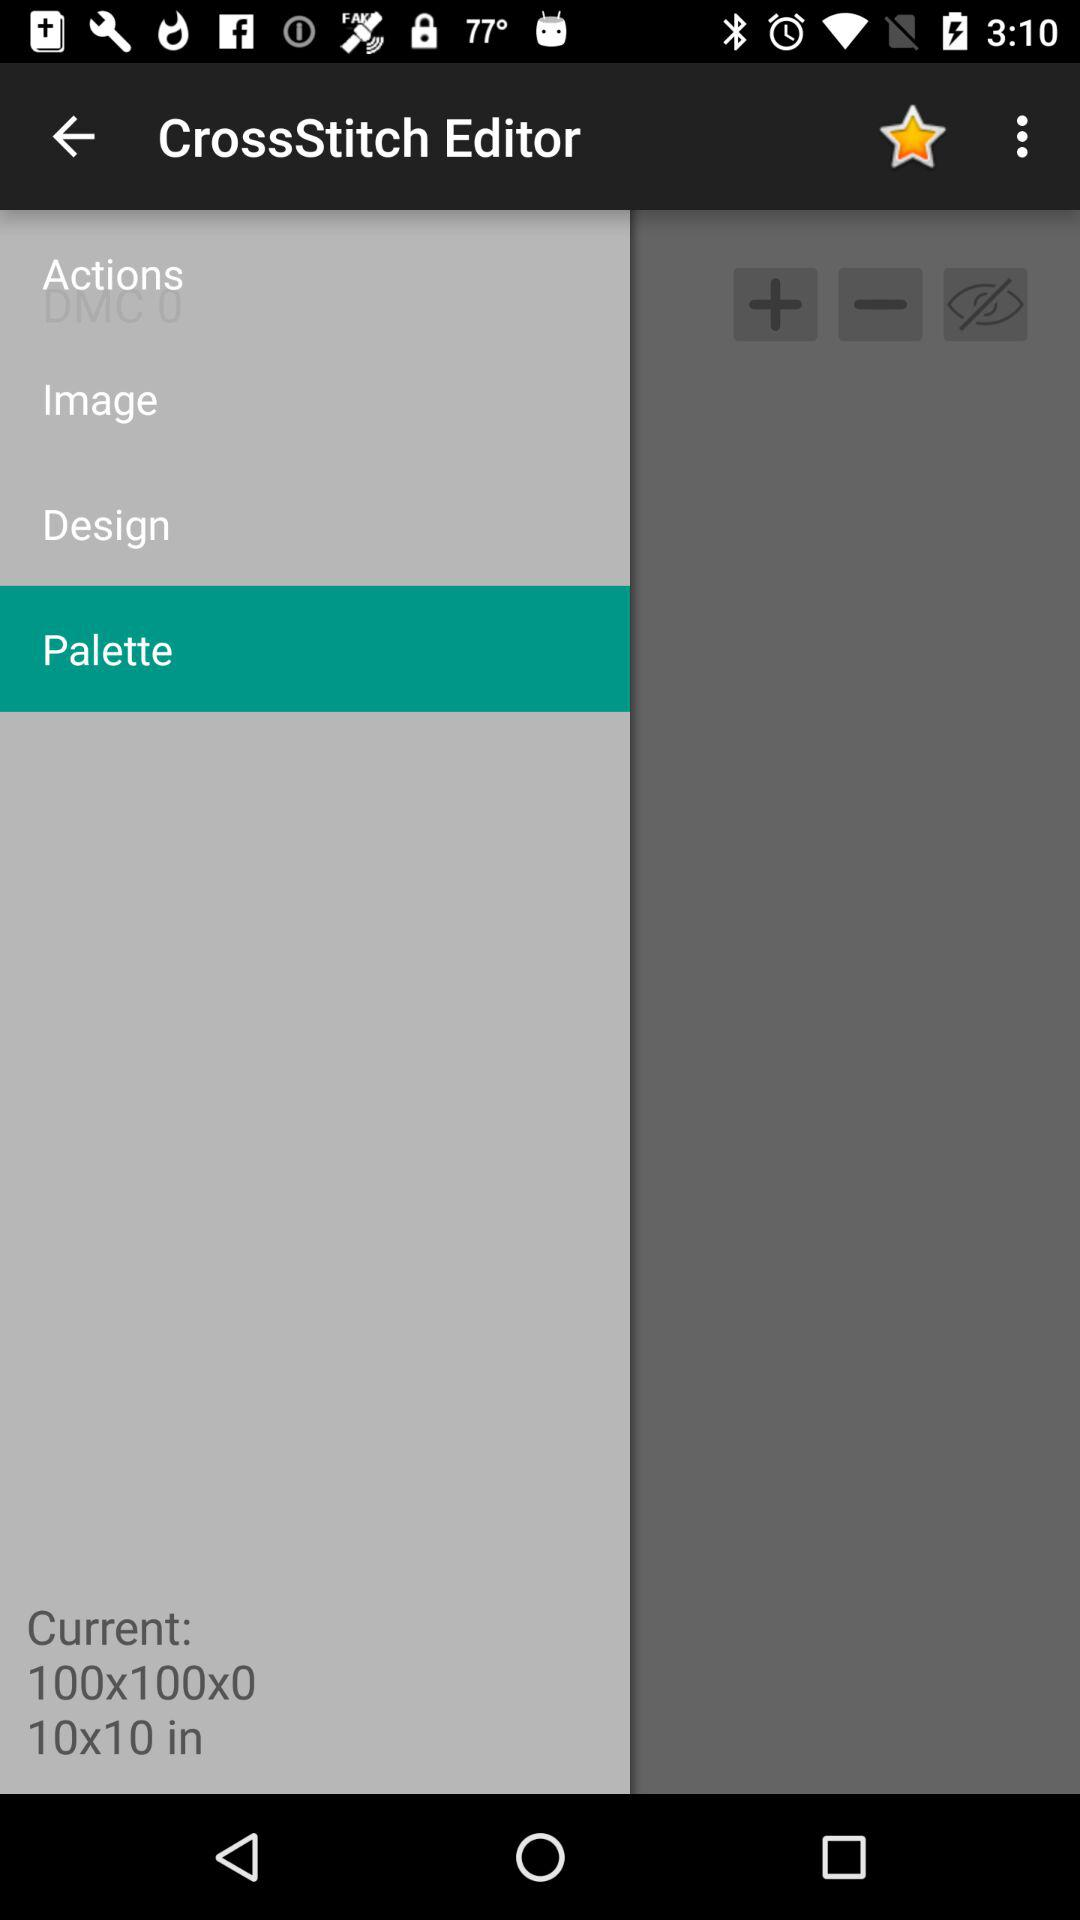What is the name of the application? The application name is "CrossStitch Editor". 